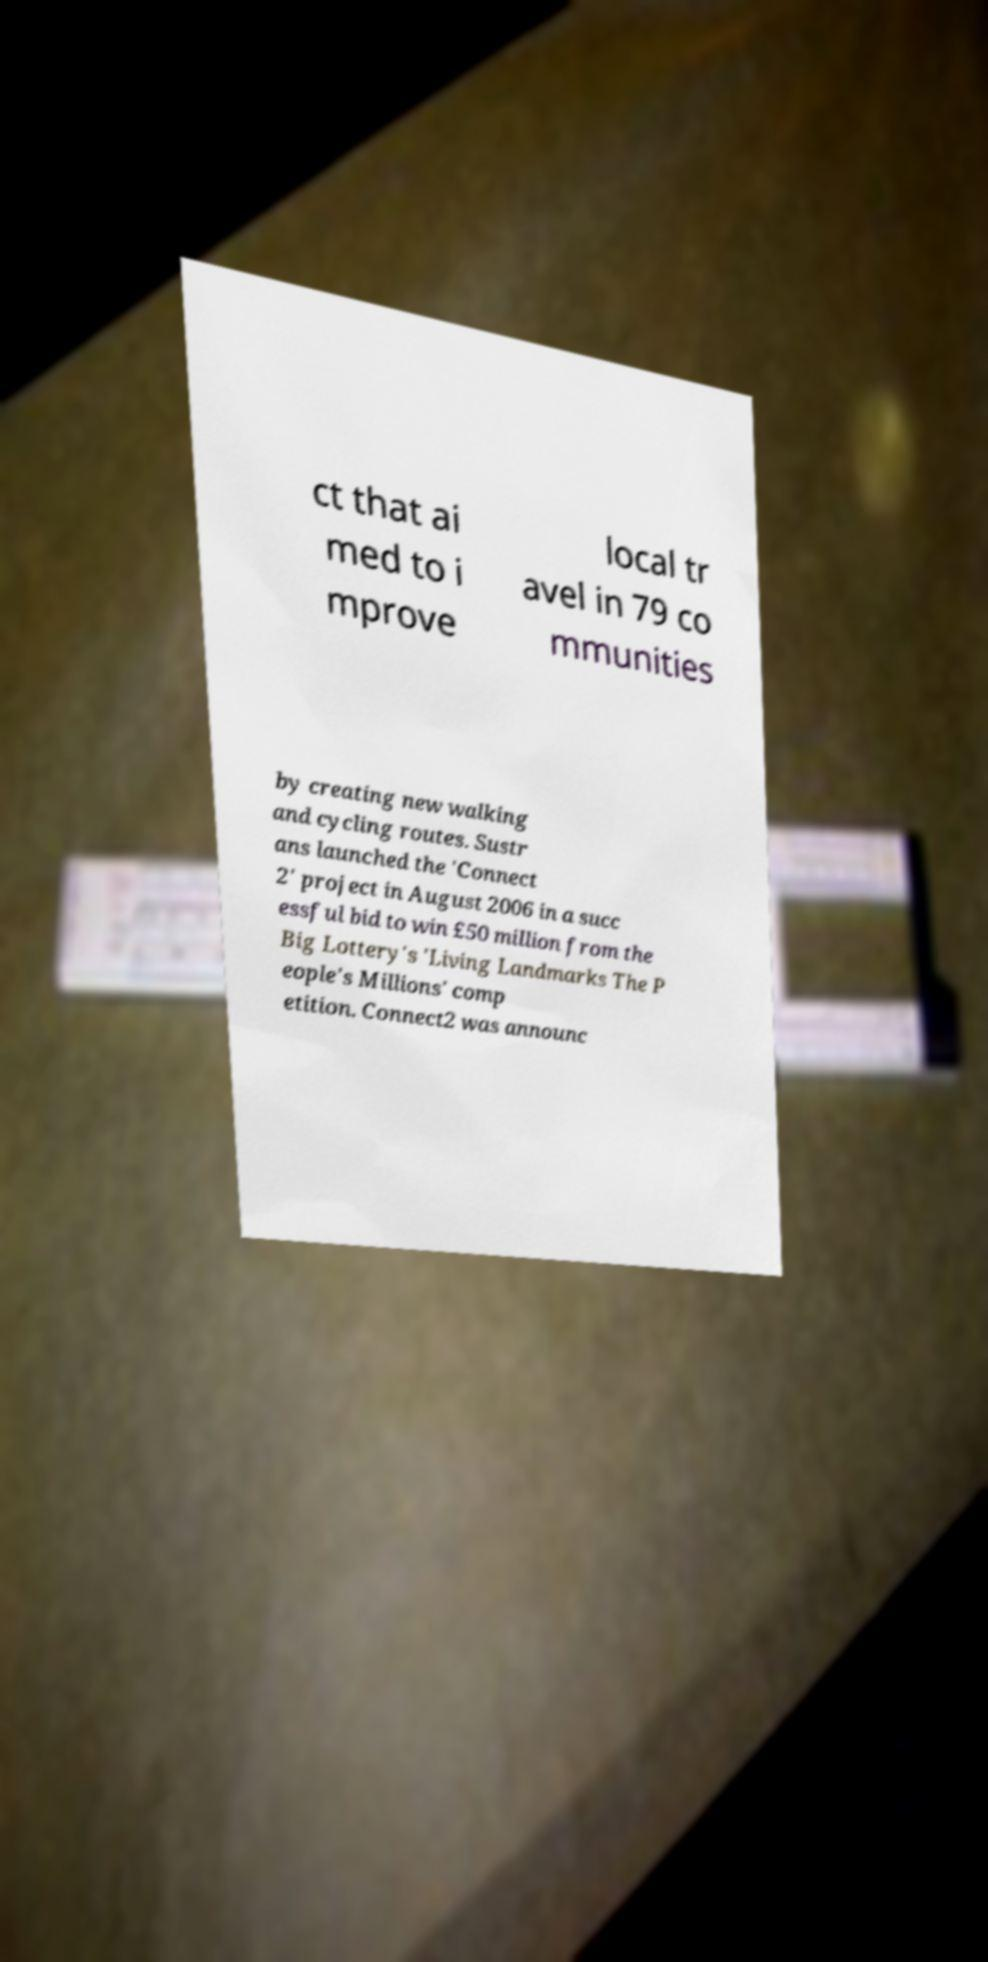What messages or text are displayed in this image? I need them in a readable, typed format. ct that ai med to i mprove local tr avel in 79 co mmunities by creating new walking and cycling routes. Sustr ans launched the 'Connect 2' project in August 2006 in a succ essful bid to win £50 million from the Big Lottery's 'Living Landmarks The P eople's Millions' comp etition. Connect2 was announc 